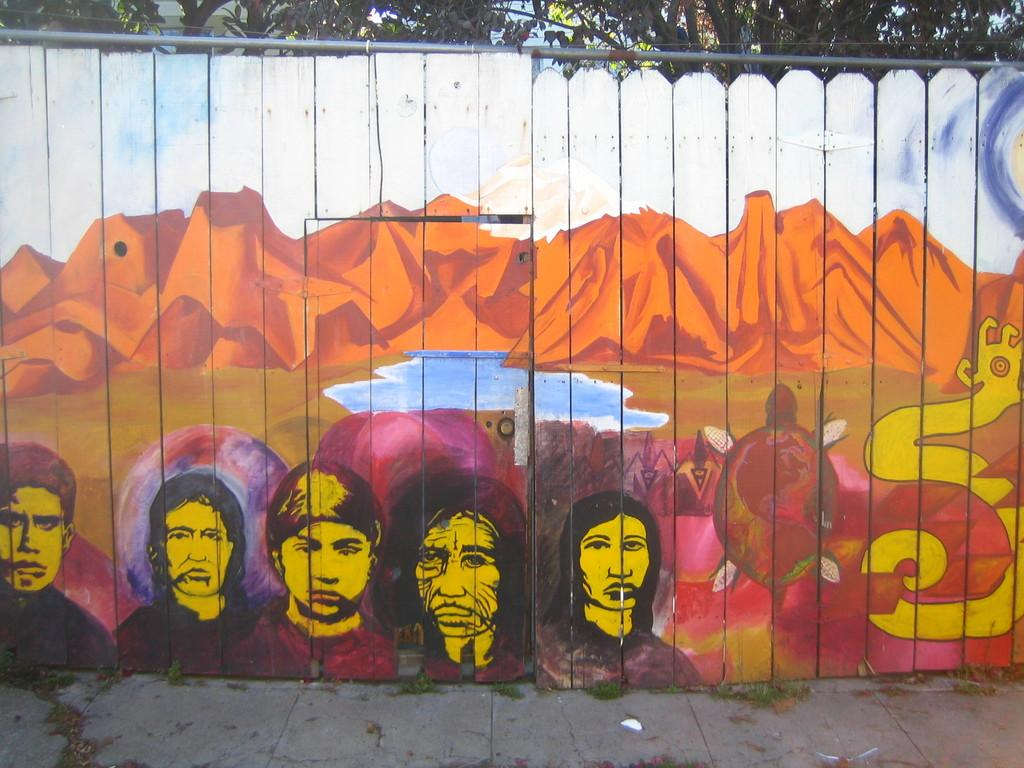What is the main feature of the fence in the image? The fence has graffiti painting of hills. What is depicted in the pond in the graffiti? There is no pond depicted in the graffiti; it is in front of the hills in the graffiti. What else can be seen in the graffiti besides the hills and pond? There are humans depicted in the graffiti. What type of vegetation is visible behind the fence? There are trees visible behind the fence. What type of soup is being served in the graffiti? There is no soup depicted in the graffiti; it features a graffiti painting of hills, a pond, and humans. Can you tell me how many hydrants are present in the graffiti? There are no hydrants present in the graffiti; it only features a painting of hills, a pond, and humans. 